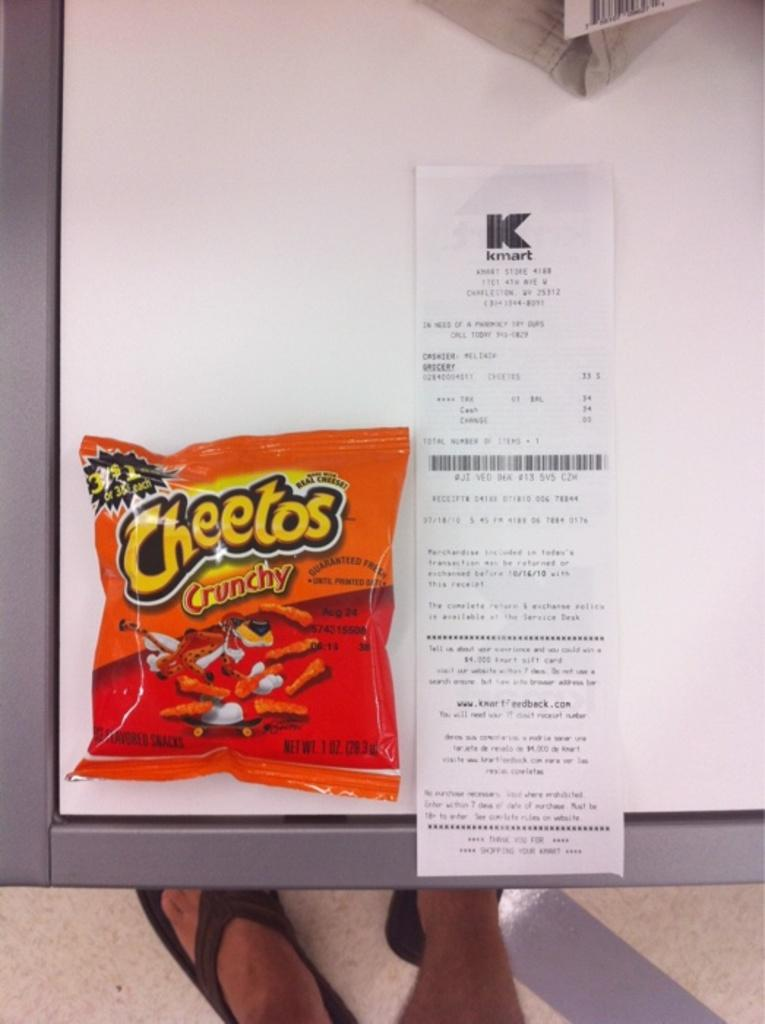What is present on the white surface in the image? There is a snacks packet and a bill on the white surface in the image. What is the color of the surface where the snacks packet and bill are placed? The surface is white. What type of surface is it? The white surface is a table. Are there any visible body parts of a person in the image? Yes, there are two legs of a person visible in the image. What type of tomatoes are being used in the operation depicted in the image? There is no operation or tomatoes present in the image. What genre of fiction is being portrayed in the image? The image does not depict any form of fiction; it shows a snacks packet, a bill, a table, and a person's legs. 